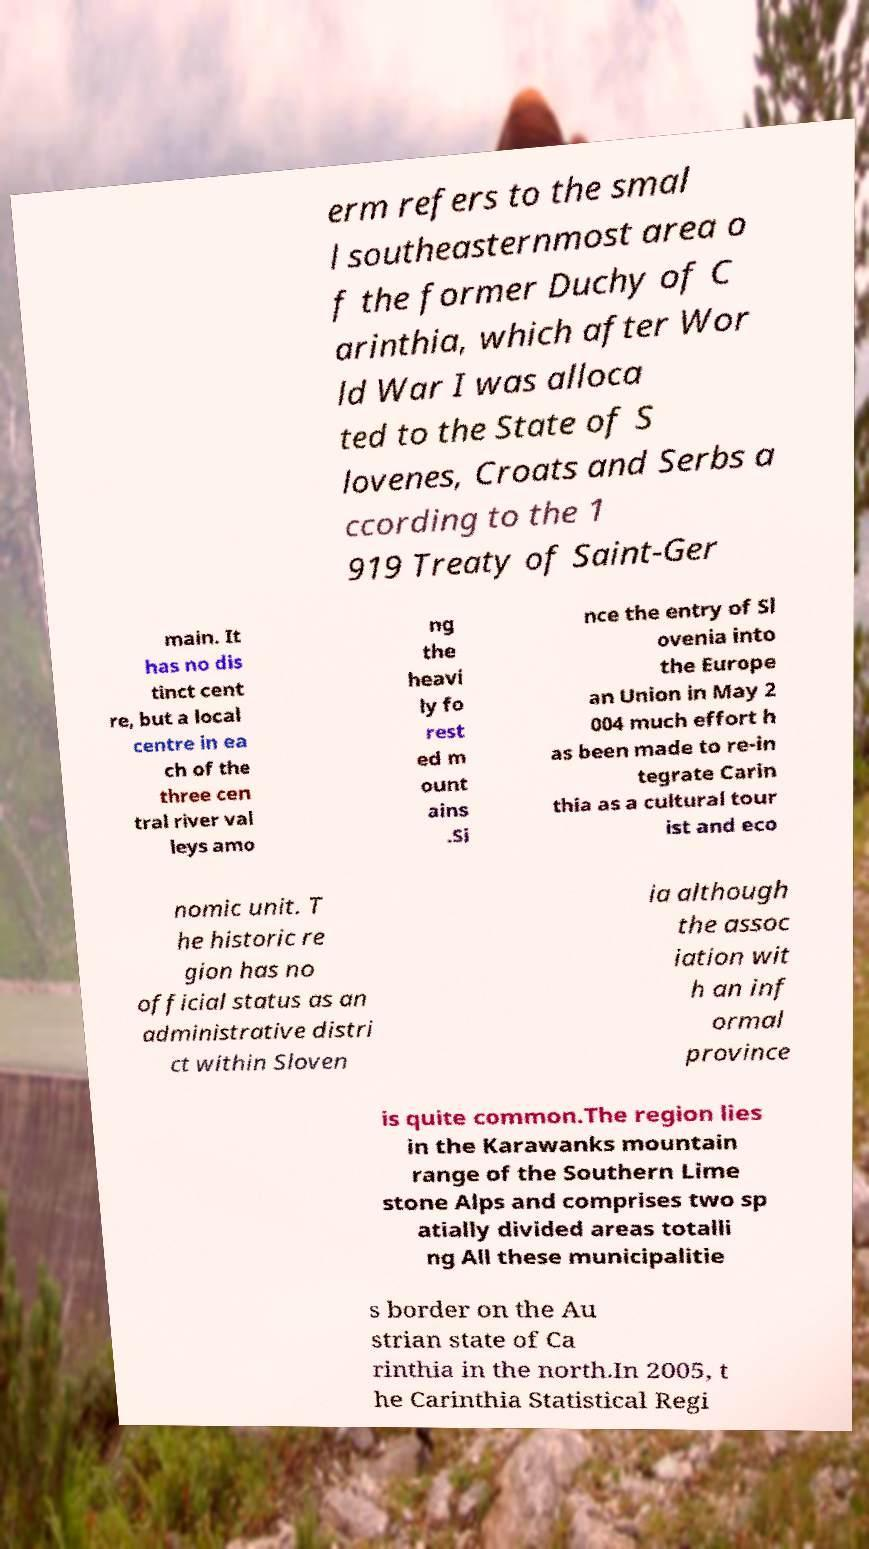What messages or text are displayed in this image? I need them in a readable, typed format. erm refers to the smal l southeasternmost area o f the former Duchy of C arinthia, which after Wor ld War I was alloca ted to the State of S lovenes, Croats and Serbs a ccording to the 1 919 Treaty of Saint-Ger main. It has no dis tinct cent re, but a local centre in ea ch of the three cen tral river val leys amo ng the heavi ly fo rest ed m ount ains .Si nce the entry of Sl ovenia into the Europe an Union in May 2 004 much effort h as been made to re-in tegrate Carin thia as a cultural tour ist and eco nomic unit. T he historic re gion has no official status as an administrative distri ct within Sloven ia although the assoc iation wit h an inf ormal province is quite common.The region lies in the Karawanks mountain range of the Southern Lime stone Alps and comprises two sp atially divided areas totalli ng All these municipalitie s border on the Au strian state of Ca rinthia in the north.In 2005, t he Carinthia Statistical Regi 